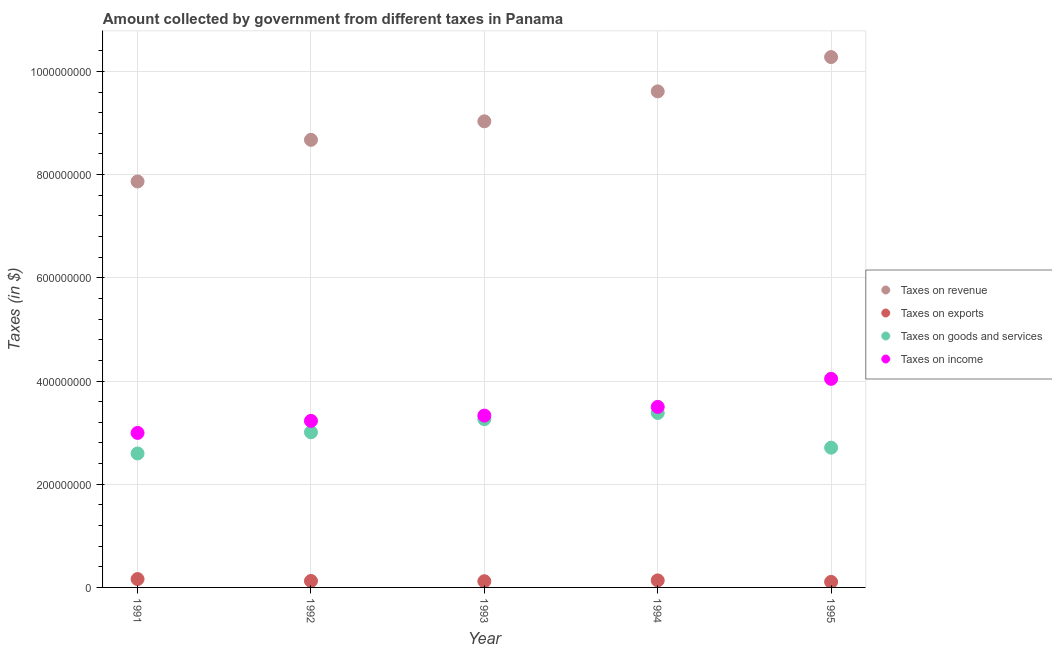Is the number of dotlines equal to the number of legend labels?
Your answer should be compact. Yes. What is the amount collected as tax on revenue in 1992?
Your response must be concise. 8.67e+08. Across all years, what is the maximum amount collected as tax on revenue?
Provide a succinct answer. 1.03e+09. Across all years, what is the minimum amount collected as tax on exports?
Give a very brief answer. 1.07e+07. In which year was the amount collected as tax on goods maximum?
Make the answer very short. 1994. In which year was the amount collected as tax on revenue minimum?
Ensure brevity in your answer.  1991. What is the total amount collected as tax on exports in the graph?
Provide a short and direct response. 6.50e+07. What is the difference between the amount collected as tax on exports in 1993 and that in 1994?
Your answer should be very brief. -1.60e+06. What is the difference between the amount collected as tax on exports in 1994 and the amount collected as tax on income in 1991?
Keep it short and to the point. -2.86e+08. What is the average amount collected as tax on exports per year?
Offer a very short reply. 1.30e+07. In the year 1994, what is the difference between the amount collected as tax on exports and amount collected as tax on revenue?
Keep it short and to the point. -9.48e+08. In how many years, is the amount collected as tax on exports greater than 160000000 $?
Your response must be concise. 0. What is the ratio of the amount collected as tax on revenue in 1994 to that in 1995?
Provide a short and direct response. 0.94. Is the difference between the amount collected as tax on income in 1993 and 1994 greater than the difference between the amount collected as tax on exports in 1993 and 1994?
Make the answer very short. No. What is the difference between the highest and the lowest amount collected as tax on revenue?
Your response must be concise. 2.41e+08. Is the sum of the amount collected as tax on goods in 1991 and 1993 greater than the maximum amount collected as tax on income across all years?
Your answer should be compact. Yes. Is it the case that in every year, the sum of the amount collected as tax on exports and amount collected as tax on revenue is greater than the sum of amount collected as tax on income and amount collected as tax on goods?
Provide a short and direct response. Yes. How many dotlines are there?
Provide a short and direct response. 4. How many years are there in the graph?
Provide a short and direct response. 5. What is the difference between two consecutive major ticks on the Y-axis?
Your response must be concise. 2.00e+08. Are the values on the major ticks of Y-axis written in scientific E-notation?
Provide a succinct answer. No. Does the graph contain grids?
Your answer should be compact. Yes. How are the legend labels stacked?
Keep it short and to the point. Vertical. What is the title of the graph?
Provide a short and direct response. Amount collected by government from different taxes in Panama. Does "Gender equality" appear as one of the legend labels in the graph?
Keep it short and to the point. No. What is the label or title of the X-axis?
Offer a terse response. Year. What is the label or title of the Y-axis?
Keep it short and to the point. Taxes (in $). What is the Taxes (in $) in Taxes on revenue in 1991?
Provide a succinct answer. 7.87e+08. What is the Taxes (in $) in Taxes on exports in 1991?
Make the answer very short. 1.62e+07. What is the Taxes (in $) of Taxes on goods and services in 1991?
Your answer should be compact. 2.60e+08. What is the Taxes (in $) in Taxes on income in 1991?
Your response must be concise. 2.99e+08. What is the Taxes (in $) in Taxes on revenue in 1992?
Offer a very short reply. 8.67e+08. What is the Taxes (in $) of Taxes on exports in 1992?
Keep it short and to the point. 1.25e+07. What is the Taxes (in $) in Taxes on goods and services in 1992?
Your answer should be very brief. 3.01e+08. What is the Taxes (in $) of Taxes on income in 1992?
Provide a succinct answer. 3.23e+08. What is the Taxes (in $) of Taxes on revenue in 1993?
Provide a short and direct response. 9.03e+08. What is the Taxes (in $) of Taxes on exports in 1993?
Ensure brevity in your answer.  1.20e+07. What is the Taxes (in $) of Taxes on goods and services in 1993?
Provide a short and direct response. 3.26e+08. What is the Taxes (in $) in Taxes on income in 1993?
Keep it short and to the point. 3.33e+08. What is the Taxes (in $) of Taxes on revenue in 1994?
Give a very brief answer. 9.61e+08. What is the Taxes (in $) in Taxes on exports in 1994?
Provide a succinct answer. 1.36e+07. What is the Taxes (in $) of Taxes on goods and services in 1994?
Offer a terse response. 3.38e+08. What is the Taxes (in $) in Taxes on income in 1994?
Offer a terse response. 3.50e+08. What is the Taxes (in $) of Taxes on revenue in 1995?
Give a very brief answer. 1.03e+09. What is the Taxes (in $) in Taxes on exports in 1995?
Make the answer very short. 1.07e+07. What is the Taxes (in $) in Taxes on goods and services in 1995?
Your answer should be very brief. 2.71e+08. What is the Taxes (in $) in Taxes on income in 1995?
Keep it short and to the point. 4.04e+08. Across all years, what is the maximum Taxes (in $) of Taxes on revenue?
Provide a succinct answer. 1.03e+09. Across all years, what is the maximum Taxes (in $) of Taxes on exports?
Make the answer very short. 1.62e+07. Across all years, what is the maximum Taxes (in $) in Taxes on goods and services?
Offer a very short reply. 3.38e+08. Across all years, what is the maximum Taxes (in $) of Taxes on income?
Make the answer very short. 4.04e+08. Across all years, what is the minimum Taxes (in $) in Taxes on revenue?
Make the answer very short. 7.87e+08. Across all years, what is the minimum Taxes (in $) of Taxes on exports?
Your response must be concise. 1.07e+07. Across all years, what is the minimum Taxes (in $) in Taxes on goods and services?
Provide a succinct answer. 2.60e+08. Across all years, what is the minimum Taxes (in $) of Taxes on income?
Provide a short and direct response. 2.99e+08. What is the total Taxes (in $) in Taxes on revenue in the graph?
Provide a succinct answer. 4.55e+09. What is the total Taxes (in $) of Taxes on exports in the graph?
Make the answer very short. 6.50e+07. What is the total Taxes (in $) of Taxes on goods and services in the graph?
Keep it short and to the point. 1.50e+09. What is the total Taxes (in $) of Taxes on income in the graph?
Ensure brevity in your answer.  1.71e+09. What is the difference between the Taxes (in $) of Taxes on revenue in 1991 and that in 1992?
Your answer should be very brief. -8.07e+07. What is the difference between the Taxes (in $) of Taxes on exports in 1991 and that in 1992?
Your response must be concise. 3.70e+06. What is the difference between the Taxes (in $) in Taxes on goods and services in 1991 and that in 1992?
Give a very brief answer. -4.11e+07. What is the difference between the Taxes (in $) of Taxes on income in 1991 and that in 1992?
Provide a succinct answer. -2.34e+07. What is the difference between the Taxes (in $) of Taxes on revenue in 1991 and that in 1993?
Ensure brevity in your answer.  -1.17e+08. What is the difference between the Taxes (in $) of Taxes on exports in 1991 and that in 1993?
Provide a succinct answer. 4.20e+06. What is the difference between the Taxes (in $) in Taxes on goods and services in 1991 and that in 1993?
Provide a short and direct response. -6.65e+07. What is the difference between the Taxes (in $) in Taxes on income in 1991 and that in 1993?
Your response must be concise. -3.36e+07. What is the difference between the Taxes (in $) of Taxes on revenue in 1991 and that in 1994?
Offer a very short reply. -1.75e+08. What is the difference between the Taxes (in $) in Taxes on exports in 1991 and that in 1994?
Ensure brevity in your answer.  2.60e+06. What is the difference between the Taxes (in $) of Taxes on goods and services in 1991 and that in 1994?
Keep it short and to the point. -7.85e+07. What is the difference between the Taxes (in $) of Taxes on income in 1991 and that in 1994?
Ensure brevity in your answer.  -5.05e+07. What is the difference between the Taxes (in $) of Taxes on revenue in 1991 and that in 1995?
Provide a succinct answer. -2.41e+08. What is the difference between the Taxes (in $) of Taxes on exports in 1991 and that in 1995?
Provide a succinct answer. 5.50e+06. What is the difference between the Taxes (in $) in Taxes on goods and services in 1991 and that in 1995?
Your answer should be very brief. -1.12e+07. What is the difference between the Taxes (in $) of Taxes on income in 1991 and that in 1995?
Keep it short and to the point. -1.05e+08. What is the difference between the Taxes (in $) in Taxes on revenue in 1992 and that in 1993?
Ensure brevity in your answer.  -3.59e+07. What is the difference between the Taxes (in $) of Taxes on exports in 1992 and that in 1993?
Give a very brief answer. 5.00e+05. What is the difference between the Taxes (in $) in Taxes on goods and services in 1992 and that in 1993?
Offer a very short reply. -2.54e+07. What is the difference between the Taxes (in $) of Taxes on income in 1992 and that in 1993?
Provide a short and direct response. -1.02e+07. What is the difference between the Taxes (in $) of Taxes on revenue in 1992 and that in 1994?
Offer a very short reply. -9.39e+07. What is the difference between the Taxes (in $) of Taxes on exports in 1992 and that in 1994?
Provide a succinct answer. -1.10e+06. What is the difference between the Taxes (in $) in Taxes on goods and services in 1992 and that in 1994?
Provide a succinct answer. -3.74e+07. What is the difference between the Taxes (in $) of Taxes on income in 1992 and that in 1994?
Provide a short and direct response. -2.71e+07. What is the difference between the Taxes (in $) in Taxes on revenue in 1992 and that in 1995?
Make the answer very short. -1.60e+08. What is the difference between the Taxes (in $) in Taxes on exports in 1992 and that in 1995?
Ensure brevity in your answer.  1.80e+06. What is the difference between the Taxes (in $) of Taxes on goods and services in 1992 and that in 1995?
Ensure brevity in your answer.  2.99e+07. What is the difference between the Taxes (in $) in Taxes on income in 1992 and that in 1995?
Your response must be concise. -8.14e+07. What is the difference between the Taxes (in $) of Taxes on revenue in 1993 and that in 1994?
Provide a succinct answer. -5.80e+07. What is the difference between the Taxes (in $) in Taxes on exports in 1993 and that in 1994?
Offer a terse response. -1.60e+06. What is the difference between the Taxes (in $) of Taxes on goods and services in 1993 and that in 1994?
Offer a terse response. -1.20e+07. What is the difference between the Taxes (in $) in Taxes on income in 1993 and that in 1994?
Your answer should be very brief. -1.69e+07. What is the difference between the Taxes (in $) in Taxes on revenue in 1993 and that in 1995?
Provide a succinct answer. -1.24e+08. What is the difference between the Taxes (in $) of Taxes on exports in 1993 and that in 1995?
Your response must be concise. 1.30e+06. What is the difference between the Taxes (in $) in Taxes on goods and services in 1993 and that in 1995?
Your answer should be very brief. 5.53e+07. What is the difference between the Taxes (in $) in Taxes on income in 1993 and that in 1995?
Your answer should be very brief. -7.12e+07. What is the difference between the Taxes (in $) in Taxes on revenue in 1994 and that in 1995?
Keep it short and to the point. -6.65e+07. What is the difference between the Taxes (in $) of Taxes on exports in 1994 and that in 1995?
Offer a very short reply. 2.90e+06. What is the difference between the Taxes (in $) of Taxes on goods and services in 1994 and that in 1995?
Ensure brevity in your answer.  6.73e+07. What is the difference between the Taxes (in $) in Taxes on income in 1994 and that in 1995?
Provide a succinct answer. -5.43e+07. What is the difference between the Taxes (in $) in Taxes on revenue in 1991 and the Taxes (in $) in Taxes on exports in 1992?
Offer a terse response. 7.74e+08. What is the difference between the Taxes (in $) of Taxes on revenue in 1991 and the Taxes (in $) of Taxes on goods and services in 1992?
Your response must be concise. 4.86e+08. What is the difference between the Taxes (in $) in Taxes on revenue in 1991 and the Taxes (in $) in Taxes on income in 1992?
Make the answer very short. 4.64e+08. What is the difference between the Taxes (in $) in Taxes on exports in 1991 and the Taxes (in $) in Taxes on goods and services in 1992?
Keep it short and to the point. -2.84e+08. What is the difference between the Taxes (in $) of Taxes on exports in 1991 and the Taxes (in $) of Taxes on income in 1992?
Offer a very short reply. -3.07e+08. What is the difference between the Taxes (in $) in Taxes on goods and services in 1991 and the Taxes (in $) in Taxes on income in 1992?
Make the answer very short. -6.32e+07. What is the difference between the Taxes (in $) in Taxes on revenue in 1991 and the Taxes (in $) in Taxes on exports in 1993?
Keep it short and to the point. 7.75e+08. What is the difference between the Taxes (in $) of Taxes on revenue in 1991 and the Taxes (in $) of Taxes on goods and services in 1993?
Offer a terse response. 4.61e+08. What is the difference between the Taxes (in $) of Taxes on revenue in 1991 and the Taxes (in $) of Taxes on income in 1993?
Offer a terse response. 4.54e+08. What is the difference between the Taxes (in $) of Taxes on exports in 1991 and the Taxes (in $) of Taxes on goods and services in 1993?
Your answer should be compact. -3.10e+08. What is the difference between the Taxes (in $) in Taxes on exports in 1991 and the Taxes (in $) in Taxes on income in 1993?
Keep it short and to the point. -3.17e+08. What is the difference between the Taxes (in $) of Taxes on goods and services in 1991 and the Taxes (in $) of Taxes on income in 1993?
Provide a short and direct response. -7.34e+07. What is the difference between the Taxes (in $) in Taxes on revenue in 1991 and the Taxes (in $) in Taxes on exports in 1994?
Keep it short and to the point. 7.73e+08. What is the difference between the Taxes (in $) of Taxes on revenue in 1991 and the Taxes (in $) of Taxes on goods and services in 1994?
Give a very brief answer. 4.49e+08. What is the difference between the Taxes (in $) of Taxes on revenue in 1991 and the Taxes (in $) of Taxes on income in 1994?
Keep it short and to the point. 4.37e+08. What is the difference between the Taxes (in $) in Taxes on exports in 1991 and the Taxes (in $) in Taxes on goods and services in 1994?
Give a very brief answer. -3.22e+08. What is the difference between the Taxes (in $) of Taxes on exports in 1991 and the Taxes (in $) of Taxes on income in 1994?
Offer a terse response. -3.34e+08. What is the difference between the Taxes (in $) in Taxes on goods and services in 1991 and the Taxes (in $) in Taxes on income in 1994?
Your response must be concise. -9.03e+07. What is the difference between the Taxes (in $) of Taxes on revenue in 1991 and the Taxes (in $) of Taxes on exports in 1995?
Provide a succinct answer. 7.76e+08. What is the difference between the Taxes (in $) of Taxes on revenue in 1991 and the Taxes (in $) of Taxes on goods and services in 1995?
Your response must be concise. 5.16e+08. What is the difference between the Taxes (in $) of Taxes on revenue in 1991 and the Taxes (in $) of Taxes on income in 1995?
Provide a short and direct response. 3.82e+08. What is the difference between the Taxes (in $) of Taxes on exports in 1991 and the Taxes (in $) of Taxes on goods and services in 1995?
Offer a terse response. -2.55e+08. What is the difference between the Taxes (in $) in Taxes on exports in 1991 and the Taxes (in $) in Taxes on income in 1995?
Provide a succinct answer. -3.88e+08. What is the difference between the Taxes (in $) in Taxes on goods and services in 1991 and the Taxes (in $) in Taxes on income in 1995?
Provide a short and direct response. -1.45e+08. What is the difference between the Taxes (in $) in Taxes on revenue in 1992 and the Taxes (in $) in Taxes on exports in 1993?
Make the answer very short. 8.55e+08. What is the difference between the Taxes (in $) in Taxes on revenue in 1992 and the Taxes (in $) in Taxes on goods and services in 1993?
Provide a short and direct response. 5.41e+08. What is the difference between the Taxes (in $) in Taxes on revenue in 1992 and the Taxes (in $) in Taxes on income in 1993?
Provide a short and direct response. 5.34e+08. What is the difference between the Taxes (in $) of Taxes on exports in 1992 and the Taxes (in $) of Taxes on goods and services in 1993?
Your response must be concise. -3.14e+08. What is the difference between the Taxes (in $) of Taxes on exports in 1992 and the Taxes (in $) of Taxes on income in 1993?
Keep it short and to the point. -3.20e+08. What is the difference between the Taxes (in $) of Taxes on goods and services in 1992 and the Taxes (in $) of Taxes on income in 1993?
Your response must be concise. -3.23e+07. What is the difference between the Taxes (in $) of Taxes on revenue in 1992 and the Taxes (in $) of Taxes on exports in 1994?
Provide a succinct answer. 8.54e+08. What is the difference between the Taxes (in $) of Taxes on revenue in 1992 and the Taxes (in $) of Taxes on goods and services in 1994?
Keep it short and to the point. 5.29e+08. What is the difference between the Taxes (in $) of Taxes on revenue in 1992 and the Taxes (in $) of Taxes on income in 1994?
Keep it short and to the point. 5.18e+08. What is the difference between the Taxes (in $) in Taxes on exports in 1992 and the Taxes (in $) in Taxes on goods and services in 1994?
Provide a succinct answer. -3.26e+08. What is the difference between the Taxes (in $) in Taxes on exports in 1992 and the Taxes (in $) in Taxes on income in 1994?
Give a very brief answer. -3.37e+08. What is the difference between the Taxes (in $) of Taxes on goods and services in 1992 and the Taxes (in $) of Taxes on income in 1994?
Your response must be concise. -4.92e+07. What is the difference between the Taxes (in $) of Taxes on revenue in 1992 and the Taxes (in $) of Taxes on exports in 1995?
Your answer should be compact. 8.57e+08. What is the difference between the Taxes (in $) of Taxes on revenue in 1992 and the Taxes (in $) of Taxes on goods and services in 1995?
Provide a short and direct response. 5.97e+08. What is the difference between the Taxes (in $) in Taxes on revenue in 1992 and the Taxes (in $) in Taxes on income in 1995?
Offer a very short reply. 4.63e+08. What is the difference between the Taxes (in $) of Taxes on exports in 1992 and the Taxes (in $) of Taxes on goods and services in 1995?
Your answer should be very brief. -2.58e+08. What is the difference between the Taxes (in $) of Taxes on exports in 1992 and the Taxes (in $) of Taxes on income in 1995?
Keep it short and to the point. -3.92e+08. What is the difference between the Taxes (in $) of Taxes on goods and services in 1992 and the Taxes (in $) of Taxes on income in 1995?
Give a very brief answer. -1.04e+08. What is the difference between the Taxes (in $) of Taxes on revenue in 1993 and the Taxes (in $) of Taxes on exports in 1994?
Make the answer very short. 8.90e+08. What is the difference between the Taxes (in $) in Taxes on revenue in 1993 and the Taxes (in $) in Taxes on goods and services in 1994?
Ensure brevity in your answer.  5.65e+08. What is the difference between the Taxes (in $) in Taxes on revenue in 1993 and the Taxes (in $) in Taxes on income in 1994?
Ensure brevity in your answer.  5.53e+08. What is the difference between the Taxes (in $) in Taxes on exports in 1993 and the Taxes (in $) in Taxes on goods and services in 1994?
Offer a very short reply. -3.26e+08. What is the difference between the Taxes (in $) of Taxes on exports in 1993 and the Taxes (in $) of Taxes on income in 1994?
Offer a terse response. -3.38e+08. What is the difference between the Taxes (in $) in Taxes on goods and services in 1993 and the Taxes (in $) in Taxes on income in 1994?
Your response must be concise. -2.38e+07. What is the difference between the Taxes (in $) of Taxes on revenue in 1993 and the Taxes (in $) of Taxes on exports in 1995?
Give a very brief answer. 8.93e+08. What is the difference between the Taxes (in $) of Taxes on revenue in 1993 and the Taxes (in $) of Taxes on goods and services in 1995?
Make the answer very short. 6.32e+08. What is the difference between the Taxes (in $) of Taxes on revenue in 1993 and the Taxes (in $) of Taxes on income in 1995?
Keep it short and to the point. 4.99e+08. What is the difference between the Taxes (in $) in Taxes on exports in 1993 and the Taxes (in $) in Taxes on goods and services in 1995?
Your answer should be compact. -2.59e+08. What is the difference between the Taxes (in $) of Taxes on exports in 1993 and the Taxes (in $) of Taxes on income in 1995?
Your answer should be very brief. -3.92e+08. What is the difference between the Taxes (in $) in Taxes on goods and services in 1993 and the Taxes (in $) in Taxes on income in 1995?
Make the answer very short. -7.81e+07. What is the difference between the Taxes (in $) in Taxes on revenue in 1994 and the Taxes (in $) in Taxes on exports in 1995?
Provide a short and direct response. 9.51e+08. What is the difference between the Taxes (in $) of Taxes on revenue in 1994 and the Taxes (in $) of Taxes on goods and services in 1995?
Provide a succinct answer. 6.90e+08. What is the difference between the Taxes (in $) of Taxes on revenue in 1994 and the Taxes (in $) of Taxes on income in 1995?
Keep it short and to the point. 5.57e+08. What is the difference between the Taxes (in $) of Taxes on exports in 1994 and the Taxes (in $) of Taxes on goods and services in 1995?
Your answer should be very brief. -2.57e+08. What is the difference between the Taxes (in $) of Taxes on exports in 1994 and the Taxes (in $) of Taxes on income in 1995?
Offer a very short reply. -3.91e+08. What is the difference between the Taxes (in $) of Taxes on goods and services in 1994 and the Taxes (in $) of Taxes on income in 1995?
Your answer should be very brief. -6.61e+07. What is the average Taxes (in $) in Taxes on revenue per year?
Make the answer very short. 9.09e+08. What is the average Taxes (in $) of Taxes on exports per year?
Your answer should be very brief. 1.30e+07. What is the average Taxes (in $) of Taxes on goods and services per year?
Keep it short and to the point. 2.99e+08. What is the average Taxes (in $) of Taxes on income per year?
Keep it short and to the point. 3.42e+08. In the year 1991, what is the difference between the Taxes (in $) in Taxes on revenue and Taxes (in $) in Taxes on exports?
Provide a succinct answer. 7.70e+08. In the year 1991, what is the difference between the Taxes (in $) in Taxes on revenue and Taxes (in $) in Taxes on goods and services?
Your response must be concise. 5.27e+08. In the year 1991, what is the difference between the Taxes (in $) of Taxes on revenue and Taxes (in $) of Taxes on income?
Provide a succinct answer. 4.87e+08. In the year 1991, what is the difference between the Taxes (in $) in Taxes on exports and Taxes (in $) in Taxes on goods and services?
Keep it short and to the point. -2.43e+08. In the year 1991, what is the difference between the Taxes (in $) of Taxes on exports and Taxes (in $) of Taxes on income?
Your answer should be compact. -2.83e+08. In the year 1991, what is the difference between the Taxes (in $) of Taxes on goods and services and Taxes (in $) of Taxes on income?
Your answer should be compact. -3.98e+07. In the year 1992, what is the difference between the Taxes (in $) of Taxes on revenue and Taxes (in $) of Taxes on exports?
Make the answer very short. 8.55e+08. In the year 1992, what is the difference between the Taxes (in $) in Taxes on revenue and Taxes (in $) in Taxes on goods and services?
Ensure brevity in your answer.  5.67e+08. In the year 1992, what is the difference between the Taxes (in $) in Taxes on revenue and Taxes (in $) in Taxes on income?
Your answer should be compact. 5.45e+08. In the year 1992, what is the difference between the Taxes (in $) in Taxes on exports and Taxes (in $) in Taxes on goods and services?
Offer a terse response. -2.88e+08. In the year 1992, what is the difference between the Taxes (in $) in Taxes on exports and Taxes (in $) in Taxes on income?
Offer a terse response. -3.10e+08. In the year 1992, what is the difference between the Taxes (in $) in Taxes on goods and services and Taxes (in $) in Taxes on income?
Ensure brevity in your answer.  -2.21e+07. In the year 1993, what is the difference between the Taxes (in $) in Taxes on revenue and Taxes (in $) in Taxes on exports?
Provide a succinct answer. 8.91e+08. In the year 1993, what is the difference between the Taxes (in $) in Taxes on revenue and Taxes (in $) in Taxes on goods and services?
Offer a very short reply. 5.77e+08. In the year 1993, what is the difference between the Taxes (in $) of Taxes on revenue and Taxes (in $) of Taxes on income?
Ensure brevity in your answer.  5.70e+08. In the year 1993, what is the difference between the Taxes (in $) in Taxes on exports and Taxes (in $) in Taxes on goods and services?
Keep it short and to the point. -3.14e+08. In the year 1993, what is the difference between the Taxes (in $) in Taxes on exports and Taxes (in $) in Taxes on income?
Ensure brevity in your answer.  -3.21e+08. In the year 1993, what is the difference between the Taxes (in $) of Taxes on goods and services and Taxes (in $) of Taxes on income?
Your answer should be very brief. -6.90e+06. In the year 1994, what is the difference between the Taxes (in $) of Taxes on revenue and Taxes (in $) of Taxes on exports?
Your answer should be compact. 9.48e+08. In the year 1994, what is the difference between the Taxes (in $) in Taxes on revenue and Taxes (in $) in Taxes on goods and services?
Provide a short and direct response. 6.23e+08. In the year 1994, what is the difference between the Taxes (in $) in Taxes on revenue and Taxes (in $) in Taxes on income?
Provide a succinct answer. 6.11e+08. In the year 1994, what is the difference between the Taxes (in $) of Taxes on exports and Taxes (in $) of Taxes on goods and services?
Provide a short and direct response. -3.24e+08. In the year 1994, what is the difference between the Taxes (in $) in Taxes on exports and Taxes (in $) in Taxes on income?
Offer a very short reply. -3.36e+08. In the year 1994, what is the difference between the Taxes (in $) in Taxes on goods and services and Taxes (in $) in Taxes on income?
Provide a short and direct response. -1.18e+07. In the year 1995, what is the difference between the Taxes (in $) of Taxes on revenue and Taxes (in $) of Taxes on exports?
Offer a very short reply. 1.02e+09. In the year 1995, what is the difference between the Taxes (in $) in Taxes on revenue and Taxes (in $) in Taxes on goods and services?
Offer a terse response. 7.57e+08. In the year 1995, what is the difference between the Taxes (in $) of Taxes on revenue and Taxes (in $) of Taxes on income?
Give a very brief answer. 6.24e+08. In the year 1995, what is the difference between the Taxes (in $) of Taxes on exports and Taxes (in $) of Taxes on goods and services?
Offer a terse response. -2.60e+08. In the year 1995, what is the difference between the Taxes (in $) of Taxes on exports and Taxes (in $) of Taxes on income?
Provide a succinct answer. -3.94e+08. In the year 1995, what is the difference between the Taxes (in $) of Taxes on goods and services and Taxes (in $) of Taxes on income?
Ensure brevity in your answer.  -1.33e+08. What is the ratio of the Taxes (in $) of Taxes on revenue in 1991 to that in 1992?
Your answer should be compact. 0.91. What is the ratio of the Taxes (in $) of Taxes on exports in 1991 to that in 1992?
Keep it short and to the point. 1.3. What is the ratio of the Taxes (in $) of Taxes on goods and services in 1991 to that in 1992?
Offer a very short reply. 0.86. What is the ratio of the Taxes (in $) of Taxes on income in 1991 to that in 1992?
Provide a short and direct response. 0.93. What is the ratio of the Taxes (in $) in Taxes on revenue in 1991 to that in 1993?
Your answer should be very brief. 0.87. What is the ratio of the Taxes (in $) in Taxes on exports in 1991 to that in 1993?
Make the answer very short. 1.35. What is the ratio of the Taxes (in $) of Taxes on goods and services in 1991 to that in 1993?
Your answer should be compact. 0.8. What is the ratio of the Taxes (in $) in Taxes on income in 1991 to that in 1993?
Provide a succinct answer. 0.9. What is the ratio of the Taxes (in $) in Taxes on revenue in 1991 to that in 1994?
Provide a succinct answer. 0.82. What is the ratio of the Taxes (in $) in Taxes on exports in 1991 to that in 1994?
Provide a succinct answer. 1.19. What is the ratio of the Taxes (in $) in Taxes on goods and services in 1991 to that in 1994?
Provide a succinct answer. 0.77. What is the ratio of the Taxes (in $) in Taxes on income in 1991 to that in 1994?
Your answer should be compact. 0.86. What is the ratio of the Taxes (in $) of Taxes on revenue in 1991 to that in 1995?
Give a very brief answer. 0.77. What is the ratio of the Taxes (in $) in Taxes on exports in 1991 to that in 1995?
Your answer should be very brief. 1.51. What is the ratio of the Taxes (in $) of Taxes on goods and services in 1991 to that in 1995?
Your answer should be very brief. 0.96. What is the ratio of the Taxes (in $) of Taxes on income in 1991 to that in 1995?
Provide a succinct answer. 0.74. What is the ratio of the Taxes (in $) of Taxes on revenue in 1992 to that in 1993?
Keep it short and to the point. 0.96. What is the ratio of the Taxes (in $) in Taxes on exports in 1992 to that in 1993?
Your answer should be very brief. 1.04. What is the ratio of the Taxes (in $) in Taxes on goods and services in 1992 to that in 1993?
Offer a terse response. 0.92. What is the ratio of the Taxes (in $) of Taxes on income in 1992 to that in 1993?
Your answer should be compact. 0.97. What is the ratio of the Taxes (in $) of Taxes on revenue in 1992 to that in 1994?
Your answer should be very brief. 0.9. What is the ratio of the Taxes (in $) in Taxes on exports in 1992 to that in 1994?
Your answer should be compact. 0.92. What is the ratio of the Taxes (in $) of Taxes on goods and services in 1992 to that in 1994?
Offer a very short reply. 0.89. What is the ratio of the Taxes (in $) in Taxes on income in 1992 to that in 1994?
Your response must be concise. 0.92. What is the ratio of the Taxes (in $) of Taxes on revenue in 1992 to that in 1995?
Ensure brevity in your answer.  0.84. What is the ratio of the Taxes (in $) in Taxes on exports in 1992 to that in 1995?
Keep it short and to the point. 1.17. What is the ratio of the Taxes (in $) in Taxes on goods and services in 1992 to that in 1995?
Your answer should be compact. 1.11. What is the ratio of the Taxes (in $) of Taxes on income in 1992 to that in 1995?
Offer a terse response. 0.8. What is the ratio of the Taxes (in $) of Taxes on revenue in 1993 to that in 1994?
Your answer should be very brief. 0.94. What is the ratio of the Taxes (in $) in Taxes on exports in 1993 to that in 1994?
Your answer should be compact. 0.88. What is the ratio of the Taxes (in $) of Taxes on goods and services in 1993 to that in 1994?
Your answer should be compact. 0.96. What is the ratio of the Taxes (in $) of Taxes on income in 1993 to that in 1994?
Offer a very short reply. 0.95. What is the ratio of the Taxes (in $) in Taxes on revenue in 1993 to that in 1995?
Keep it short and to the point. 0.88. What is the ratio of the Taxes (in $) in Taxes on exports in 1993 to that in 1995?
Ensure brevity in your answer.  1.12. What is the ratio of the Taxes (in $) of Taxes on goods and services in 1993 to that in 1995?
Provide a short and direct response. 1.2. What is the ratio of the Taxes (in $) of Taxes on income in 1993 to that in 1995?
Provide a succinct answer. 0.82. What is the ratio of the Taxes (in $) in Taxes on revenue in 1994 to that in 1995?
Offer a very short reply. 0.94. What is the ratio of the Taxes (in $) in Taxes on exports in 1994 to that in 1995?
Offer a very short reply. 1.27. What is the ratio of the Taxes (in $) in Taxes on goods and services in 1994 to that in 1995?
Make the answer very short. 1.25. What is the ratio of the Taxes (in $) in Taxes on income in 1994 to that in 1995?
Keep it short and to the point. 0.87. What is the difference between the highest and the second highest Taxes (in $) of Taxes on revenue?
Keep it short and to the point. 6.65e+07. What is the difference between the highest and the second highest Taxes (in $) in Taxes on exports?
Keep it short and to the point. 2.60e+06. What is the difference between the highest and the second highest Taxes (in $) of Taxes on goods and services?
Keep it short and to the point. 1.20e+07. What is the difference between the highest and the second highest Taxes (in $) in Taxes on income?
Your response must be concise. 5.43e+07. What is the difference between the highest and the lowest Taxes (in $) of Taxes on revenue?
Provide a short and direct response. 2.41e+08. What is the difference between the highest and the lowest Taxes (in $) of Taxes on exports?
Provide a short and direct response. 5.50e+06. What is the difference between the highest and the lowest Taxes (in $) of Taxes on goods and services?
Give a very brief answer. 7.85e+07. What is the difference between the highest and the lowest Taxes (in $) in Taxes on income?
Offer a very short reply. 1.05e+08. 